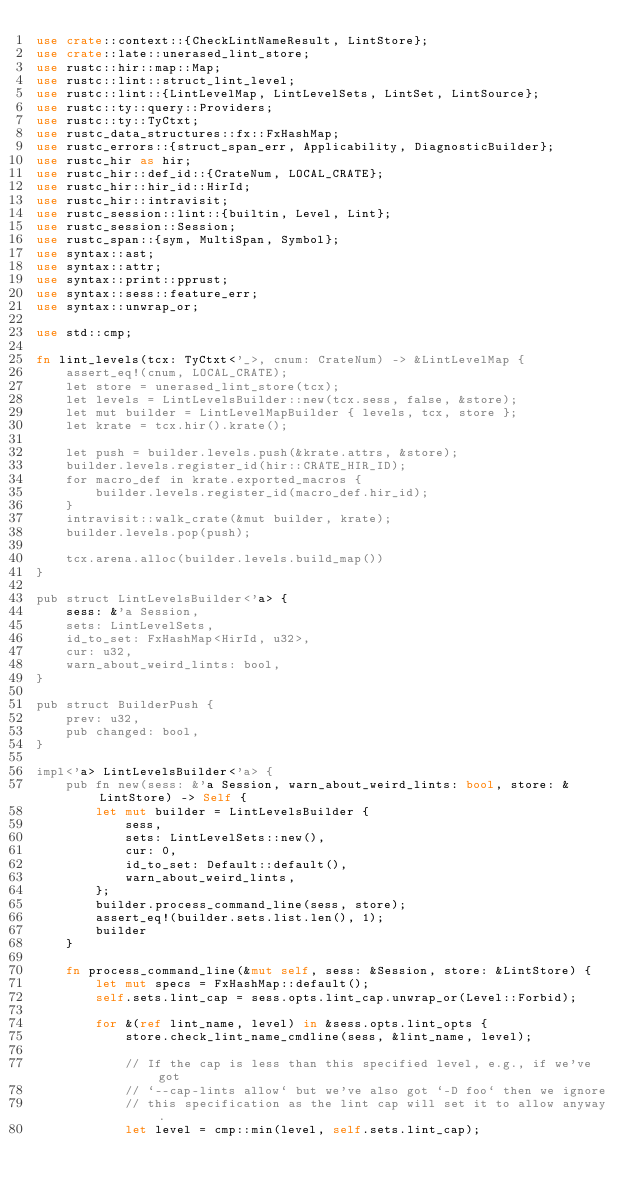Convert code to text. <code><loc_0><loc_0><loc_500><loc_500><_Rust_>use crate::context::{CheckLintNameResult, LintStore};
use crate::late::unerased_lint_store;
use rustc::hir::map::Map;
use rustc::lint::struct_lint_level;
use rustc::lint::{LintLevelMap, LintLevelSets, LintSet, LintSource};
use rustc::ty::query::Providers;
use rustc::ty::TyCtxt;
use rustc_data_structures::fx::FxHashMap;
use rustc_errors::{struct_span_err, Applicability, DiagnosticBuilder};
use rustc_hir as hir;
use rustc_hir::def_id::{CrateNum, LOCAL_CRATE};
use rustc_hir::hir_id::HirId;
use rustc_hir::intravisit;
use rustc_session::lint::{builtin, Level, Lint};
use rustc_session::Session;
use rustc_span::{sym, MultiSpan, Symbol};
use syntax::ast;
use syntax::attr;
use syntax::print::pprust;
use syntax::sess::feature_err;
use syntax::unwrap_or;

use std::cmp;

fn lint_levels(tcx: TyCtxt<'_>, cnum: CrateNum) -> &LintLevelMap {
    assert_eq!(cnum, LOCAL_CRATE);
    let store = unerased_lint_store(tcx);
    let levels = LintLevelsBuilder::new(tcx.sess, false, &store);
    let mut builder = LintLevelMapBuilder { levels, tcx, store };
    let krate = tcx.hir().krate();

    let push = builder.levels.push(&krate.attrs, &store);
    builder.levels.register_id(hir::CRATE_HIR_ID);
    for macro_def in krate.exported_macros {
        builder.levels.register_id(macro_def.hir_id);
    }
    intravisit::walk_crate(&mut builder, krate);
    builder.levels.pop(push);

    tcx.arena.alloc(builder.levels.build_map())
}

pub struct LintLevelsBuilder<'a> {
    sess: &'a Session,
    sets: LintLevelSets,
    id_to_set: FxHashMap<HirId, u32>,
    cur: u32,
    warn_about_weird_lints: bool,
}

pub struct BuilderPush {
    prev: u32,
    pub changed: bool,
}

impl<'a> LintLevelsBuilder<'a> {
    pub fn new(sess: &'a Session, warn_about_weird_lints: bool, store: &LintStore) -> Self {
        let mut builder = LintLevelsBuilder {
            sess,
            sets: LintLevelSets::new(),
            cur: 0,
            id_to_set: Default::default(),
            warn_about_weird_lints,
        };
        builder.process_command_line(sess, store);
        assert_eq!(builder.sets.list.len(), 1);
        builder
    }

    fn process_command_line(&mut self, sess: &Session, store: &LintStore) {
        let mut specs = FxHashMap::default();
        self.sets.lint_cap = sess.opts.lint_cap.unwrap_or(Level::Forbid);

        for &(ref lint_name, level) in &sess.opts.lint_opts {
            store.check_lint_name_cmdline(sess, &lint_name, level);

            // If the cap is less than this specified level, e.g., if we've got
            // `--cap-lints allow` but we've also got `-D foo` then we ignore
            // this specification as the lint cap will set it to allow anyway.
            let level = cmp::min(level, self.sets.lint_cap);
</code> 